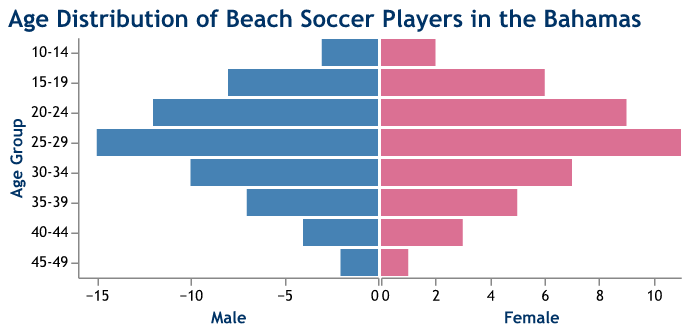What is the most populous age group for male beach soccer players? The bars on the left of the figure represent male players. The highest bar among them is for the age group 25-29.
Answer: 25-29 What is the difference in the number of players between the age groups 20-24 and 35-39 for females? The bars on the right of the figure represent female players. For the age group 20-24, the count is 9, and for 35-39, it is 5. The difference is 9 - 5.
Answer: 4 Which age group has more female players than male players? Compare the heights of bars on the left and right for all age groups. None of the age groups have more female players than male players.
Answer: None What are the total number of male beach soccer players? Sum the values of male players across all age groups: 3 + 8 + 12 + 15 + 10 + 7 + 4 + 2.
Answer: 61 In which age group is the gap between the number of male and female players the smallest? Compare the difference in heights between bars on the left and the right for all age groups. The smallest difference is in the age group 10-14, with a difference of 1 (3 males and 2 females).
Answer: 10-14 Which gender has the highest count in any single age group? Compare the highest values for each gender. The highest count is 15 male players in the age group 25-29.
Answer: Male How does the number of female players in the 30-34 age group compare to the total number of players in the 40-44 age group for both genders? The number of female players in the 30-34 age group is 7. The total number of players in the 40-44 age group for both genders is 4 (male) + 3 (female) = 7.
Answer: Equal What is the combined total of male and female players in the 15-19 and 25-29 age groups? For 15-19: 8 (male) + 6 (female) = 14. For 25-29: 15 (male) + 11 (female) = 26. The combined total is 14 + 26.
Answer: 40 Which age group has the fewest number of female players? Look for the shortest bar on the right side of the figure. The age group 45-49 has the fewest female players with 1.
Answer: 45-49 